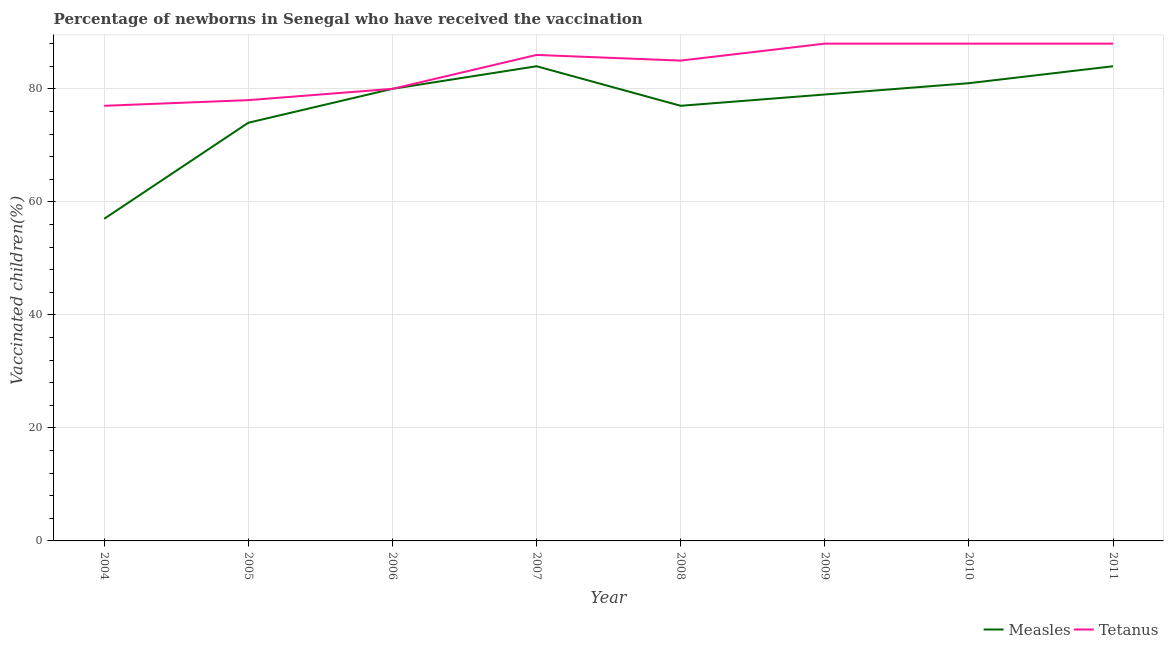How many different coloured lines are there?
Ensure brevity in your answer.  2. Does the line corresponding to percentage of newborns who received vaccination for measles intersect with the line corresponding to percentage of newborns who received vaccination for tetanus?
Make the answer very short. Yes. Is the number of lines equal to the number of legend labels?
Your response must be concise. Yes. What is the percentage of newborns who received vaccination for tetanus in 2009?
Provide a short and direct response. 88. Across all years, what is the maximum percentage of newborns who received vaccination for measles?
Make the answer very short. 84. Across all years, what is the minimum percentage of newborns who received vaccination for tetanus?
Give a very brief answer. 77. In which year was the percentage of newborns who received vaccination for tetanus minimum?
Your answer should be compact. 2004. What is the total percentage of newborns who received vaccination for measles in the graph?
Your response must be concise. 616. What is the difference between the percentage of newborns who received vaccination for measles in 2009 and that in 2011?
Your answer should be very brief. -5. What is the difference between the percentage of newborns who received vaccination for tetanus in 2009 and the percentage of newborns who received vaccination for measles in 2005?
Offer a terse response. 14. In the year 2009, what is the difference between the percentage of newborns who received vaccination for tetanus and percentage of newborns who received vaccination for measles?
Your answer should be very brief. 9. In how many years, is the percentage of newborns who received vaccination for measles greater than 16 %?
Your answer should be very brief. 8. What is the ratio of the percentage of newborns who received vaccination for measles in 2004 to that in 2008?
Keep it short and to the point. 0.74. What is the difference between the highest and the lowest percentage of newborns who received vaccination for measles?
Keep it short and to the point. 27. In how many years, is the percentage of newborns who received vaccination for measles greater than the average percentage of newborns who received vaccination for measles taken over all years?
Offer a very short reply. 5. Is the sum of the percentage of newborns who received vaccination for measles in 2006 and 2008 greater than the maximum percentage of newborns who received vaccination for tetanus across all years?
Provide a short and direct response. Yes. Does the percentage of newborns who received vaccination for measles monotonically increase over the years?
Provide a short and direct response. No. Does the graph contain any zero values?
Make the answer very short. No. Does the graph contain grids?
Ensure brevity in your answer.  Yes. Where does the legend appear in the graph?
Make the answer very short. Bottom right. What is the title of the graph?
Make the answer very short. Percentage of newborns in Senegal who have received the vaccination. Does "Male" appear as one of the legend labels in the graph?
Provide a short and direct response. No. What is the label or title of the Y-axis?
Provide a succinct answer. Vaccinated children(%)
. What is the Vaccinated children(%)
 of Measles in 2004?
Keep it short and to the point. 57. What is the Vaccinated children(%)
 in Measles in 2005?
Offer a very short reply. 74. What is the Vaccinated children(%)
 of Tetanus in 2006?
Offer a very short reply. 80. What is the Vaccinated children(%)
 in Measles in 2009?
Your answer should be very brief. 79. Across all years, what is the maximum Vaccinated children(%)
 of Tetanus?
Provide a short and direct response. 88. Across all years, what is the minimum Vaccinated children(%)
 in Tetanus?
Offer a very short reply. 77. What is the total Vaccinated children(%)
 in Measles in the graph?
Keep it short and to the point. 616. What is the total Vaccinated children(%)
 in Tetanus in the graph?
Your answer should be very brief. 670. What is the difference between the Vaccinated children(%)
 of Measles in 2004 and that in 2006?
Ensure brevity in your answer.  -23. What is the difference between the Vaccinated children(%)
 in Tetanus in 2004 and that in 2007?
Your answer should be very brief. -9. What is the difference between the Vaccinated children(%)
 of Tetanus in 2004 and that in 2008?
Give a very brief answer. -8. What is the difference between the Vaccinated children(%)
 in Tetanus in 2004 and that in 2009?
Give a very brief answer. -11. What is the difference between the Vaccinated children(%)
 of Measles in 2004 and that in 2011?
Your answer should be very brief. -27. What is the difference between the Vaccinated children(%)
 of Tetanus in 2004 and that in 2011?
Keep it short and to the point. -11. What is the difference between the Vaccinated children(%)
 of Tetanus in 2005 and that in 2006?
Your response must be concise. -2. What is the difference between the Vaccinated children(%)
 of Measles in 2005 and that in 2007?
Provide a short and direct response. -10. What is the difference between the Vaccinated children(%)
 of Tetanus in 2005 and that in 2007?
Make the answer very short. -8. What is the difference between the Vaccinated children(%)
 in Measles in 2005 and that in 2008?
Keep it short and to the point. -3. What is the difference between the Vaccinated children(%)
 in Tetanus in 2005 and that in 2008?
Keep it short and to the point. -7. What is the difference between the Vaccinated children(%)
 of Measles in 2005 and that in 2009?
Your answer should be compact. -5. What is the difference between the Vaccinated children(%)
 of Measles in 2005 and that in 2010?
Make the answer very short. -7. What is the difference between the Vaccinated children(%)
 of Tetanus in 2005 and that in 2011?
Make the answer very short. -10. What is the difference between the Vaccinated children(%)
 in Tetanus in 2006 and that in 2008?
Your response must be concise. -5. What is the difference between the Vaccinated children(%)
 in Measles in 2006 and that in 2009?
Give a very brief answer. 1. What is the difference between the Vaccinated children(%)
 of Tetanus in 2006 and that in 2011?
Give a very brief answer. -8. What is the difference between the Vaccinated children(%)
 in Tetanus in 2007 and that in 2008?
Your answer should be very brief. 1. What is the difference between the Vaccinated children(%)
 in Measles in 2007 and that in 2009?
Provide a short and direct response. 5. What is the difference between the Vaccinated children(%)
 in Tetanus in 2007 and that in 2009?
Your answer should be compact. -2. What is the difference between the Vaccinated children(%)
 in Measles in 2007 and that in 2010?
Offer a terse response. 3. What is the difference between the Vaccinated children(%)
 in Measles in 2007 and that in 2011?
Provide a succinct answer. 0. What is the difference between the Vaccinated children(%)
 of Tetanus in 2007 and that in 2011?
Your answer should be very brief. -2. What is the difference between the Vaccinated children(%)
 of Measles in 2008 and that in 2009?
Your answer should be very brief. -2. What is the difference between the Vaccinated children(%)
 of Tetanus in 2008 and that in 2009?
Give a very brief answer. -3. What is the difference between the Vaccinated children(%)
 of Measles in 2008 and that in 2010?
Provide a short and direct response. -4. What is the difference between the Vaccinated children(%)
 in Tetanus in 2008 and that in 2010?
Your response must be concise. -3. What is the difference between the Vaccinated children(%)
 of Measles in 2008 and that in 2011?
Provide a short and direct response. -7. What is the difference between the Vaccinated children(%)
 in Measles in 2009 and that in 2010?
Offer a terse response. -2. What is the difference between the Vaccinated children(%)
 in Measles in 2009 and that in 2011?
Offer a terse response. -5. What is the difference between the Vaccinated children(%)
 of Measles in 2010 and that in 2011?
Provide a short and direct response. -3. What is the difference between the Vaccinated children(%)
 in Tetanus in 2010 and that in 2011?
Your response must be concise. 0. What is the difference between the Vaccinated children(%)
 of Measles in 2004 and the Vaccinated children(%)
 of Tetanus in 2005?
Your answer should be very brief. -21. What is the difference between the Vaccinated children(%)
 of Measles in 2004 and the Vaccinated children(%)
 of Tetanus in 2009?
Give a very brief answer. -31. What is the difference between the Vaccinated children(%)
 in Measles in 2004 and the Vaccinated children(%)
 in Tetanus in 2010?
Keep it short and to the point. -31. What is the difference between the Vaccinated children(%)
 in Measles in 2004 and the Vaccinated children(%)
 in Tetanus in 2011?
Provide a succinct answer. -31. What is the difference between the Vaccinated children(%)
 of Measles in 2005 and the Vaccinated children(%)
 of Tetanus in 2007?
Offer a very short reply. -12. What is the difference between the Vaccinated children(%)
 of Measles in 2005 and the Vaccinated children(%)
 of Tetanus in 2008?
Your answer should be compact. -11. What is the difference between the Vaccinated children(%)
 in Measles in 2005 and the Vaccinated children(%)
 in Tetanus in 2011?
Provide a succinct answer. -14. What is the difference between the Vaccinated children(%)
 of Measles in 2006 and the Vaccinated children(%)
 of Tetanus in 2007?
Your answer should be very brief. -6. What is the difference between the Vaccinated children(%)
 in Measles in 2006 and the Vaccinated children(%)
 in Tetanus in 2008?
Offer a terse response. -5. What is the difference between the Vaccinated children(%)
 of Measles in 2006 and the Vaccinated children(%)
 of Tetanus in 2009?
Offer a terse response. -8. What is the difference between the Vaccinated children(%)
 in Measles in 2006 and the Vaccinated children(%)
 in Tetanus in 2011?
Give a very brief answer. -8. What is the difference between the Vaccinated children(%)
 in Measles in 2007 and the Vaccinated children(%)
 in Tetanus in 2008?
Provide a succinct answer. -1. What is the difference between the Vaccinated children(%)
 in Measles in 2007 and the Vaccinated children(%)
 in Tetanus in 2010?
Ensure brevity in your answer.  -4. What is the difference between the Vaccinated children(%)
 of Measles in 2008 and the Vaccinated children(%)
 of Tetanus in 2009?
Provide a succinct answer. -11. What is the difference between the Vaccinated children(%)
 in Measles in 2008 and the Vaccinated children(%)
 in Tetanus in 2011?
Your response must be concise. -11. What is the difference between the Vaccinated children(%)
 of Measles in 2009 and the Vaccinated children(%)
 of Tetanus in 2010?
Your answer should be compact. -9. What is the average Vaccinated children(%)
 of Tetanus per year?
Offer a very short reply. 83.75. In the year 2004, what is the difference between the Vaccinated children(%)
 of Measles and Vaccinated children(%)
 of Tetanus?
Your answer should be very brief. -20. In the year 2005, what is the difference between the Vaccinated children(%)
 of Measles and Vaccinated children(%)
 of Tetanus?
Your response must be concise. -4. In the year 2006, what is the difference between the Vaccinated children(%)
 of Measles and Vaccinated children(%)
 of Tetanus?
Offer a terse response. 0. In the year 2007, what is the difference between the Vaccinated children(%)
 in Measles and Vaccinated children(%)
 in Tetanus?
Give a very brief answer. -2. In the year 2009, what is the difference between the Vaccinated children(%)
 of Measles and Vaccinated children(%)
 of Tetanus?
Make the answer very short. -9. What is the ratio of the Vaccinated children(%)
 of Measles in 2004 to that in 2005?
Provide a short and direct response. 0.77. What is the ratio of the Vaccinated children(%)
 in Tetanus in 2004 to that in 2005?
Keep it short and to the point. 0.99. What is the ratio of the Vaccinated children(%)
 of Measles in 2004 to that in 2006?
Give a very brief answer. 0.71. What is the ratio of the Vaccinated children(%)
 in Tetanus in 2004 to that in 2006?
Provide a short and direct response. 0.96. What is the ratio of the Vaccinated children(%)
 in Measles in 2004 to that in 2007?
Offer a very short reply. 0.68. What is the ratio of the Vaccinated children(%)
 in Tetanus in 2004 to that in 2007?
Your answer should be very brief. 0.9. What is the ratio of the Vaccinated children(%)
 of Measles in 2004 to that in 2008?
Ensure brevity in your answer.  0.74. What is the ratio of the Vaccinated children(%)
 of Tetanus in 2004 to that in 2008?
Offer a terse response. 0.91. What is the ratio of the Vaccinated children(%)
 in Measles in 2004 to that in 2009?
Make the answer very short. 0.72. What is the ratio of the Vaccinated children(%)
 of Tetanus in 2004 to that in 2009?
Offer a very short reply. 0.88. What is the ratio of the Vaccinated children(%)
 in Measles in 2004 to that in 2010?
Provide a succinct answer. 0.7. What is the ratio of the Vaccinated children(%)
 in Tetanus in 2004 to that in 2010?
Offer a very short reply. 0.88. What is the ratio of the Vaccinated children(%)
 of Measles in 2004 to that in 2011?
Offer a very short reply. 0.68. What is the ratio of the Vaccinated children(%)
 in Measles in 2005 to that in 2006?
Keep it short and to the point. 0.93. What is the ratio of the Vaccinated children(%)
 of Measles in 2005 to that in 2007?
Ensure brevity in your answer.  0.88. What is the ratio of the Vaccinated children(%)
 of Tetanus in 2005 to that in 2007?
Your response must be concise. 0.91. What is the ratio of the Vaccinated children(%)
 in Measles in 2005 to that in 2008?
Your answer should be compact. 0.96. What is the ratio of the Vaccinated children(%)
 in Tetanus in 2005 to that in 2008?
Give a very brief answer. 0.92. What is the ratio of the Vaccinated children(%)
 in Measles in 2005 to that in 2009?
Provide a succinct answer. 0.94. What is the ratio of the Vaccinated children(%)
 of Tetanus in 2005 to that in 2009?
Provide a succinct answer. 0.89. What is the ratio of the Vaccinated children(%)
 in Measles in 2005 to that in 2010?
Offer a very short reply. 0.91. What is the ratio of the Vaccinated children(%)
 in Tetanus in 2005 to that in 2010?
Offer a terse response. 0.89. What is the ratio of the Vaccinated children(%)
 of Measles in 2005 to that in 2011?
Offer a very short reply. 0.88. What is the ratio of the Vaccinated children(%)
 in Tetanus in 2005 to that in 2011?
Offer a very short reply. 0.89. What is the ratio of the Vaccinated children(%)
 in Tetanus in 2006 to that in 2007?
Offer a very short reply. 0.93. What is the ratio of the Vaccinated children(%)
 in Measles in 2006 to that in 2008?
Make the answer very short. 1.04. What is the ratio of the Vaccinated children(%)
 in Measles in 2006 to that in 2009?
Give a very brief answer. 1.01. What is the ratio of the Vaccinated children(%)
 of Tetanus in 2006 to that in 2009?
Provide a succinct answer. 0.91. What is the ratio of the Vaccinated children(%)
 in Tetanus in 2006 to that in 2010?
Offer a terse response. 0.91. What is the ratio of the Vaccinated children(%)
 in Tetanus in 2006 to that in 2011?
Provide a succinct answer. 0.91. What is the ratio of the Vaccinated children(%)
 in Measles in 2007 to that in 2008?
Your answer should be very brief. 1.09. What is the ratio of the Vaccinated children(%)
 in Tetanus in 2007 to that in 2008?
Your answer should be very brief. 1.01. What is the ratio of the Vaccinated children(%)
 of Measles in 2007 to that in 2009?
Offer a very short reply. 1.06. What is the ratio of the Vaccinated children(%)
 of Tetanus in 2007 to that in 2009?
Give a very brief answer. 0.98. What is the ratio of the Vaccinated children(%)
 in Tetanus in 2007 to that in 2010?
Keep it short and to the point. 0.98. What is the ratio of the Vaccinated children(%)
 in Tetanus in 2007 to that in 2011?
Make the answer very short. 0.98. What is the ratio of the Vaccinated children(%)
 in Measles in 2008 to that in 2009?
Offer a very short reply. 0.97. What is the ratio of the Vaccinated children(%)
 in Tetanus in 2008 to that in 2009?
Your response must be concise. 0.97. What is the ratio of the Vaccinated children(%)
 of Measles in 2008 to that in 2010?
Provide a succinct answer. 0.95. What is the ratio of the Vaccinated children(%)
 of Tetanus in 2008 to that in 2010?
Ensure brevity in your answer.  0.97. What is the ratio of the Vaccinated children(%)
 in Measles in 2008 to that in 2011?
Provide a succinct answer. 0.92. What is the ratio of the Vaccinated children(%)
 in Tetanus in 2008 to that in 2011?
Provide a succinct answer. 0.97. What is the ratio of the Vaccinated children(%)
 in Measles in 2009 to that in 2010?
Provide a short and direct response. 0.98. What is the ratio of the Vaccinated children(%)
 of Tetanus in 2009 to that in 2010?
Your answer should be very brief. 1. What is the ratio of the Vaccinated children(%)
 of Measles in 2009 to that in 2011?
Make the answer very short. 0.94. What is the ratio of the Vaccinated children(%)
 of Measles in 2010 to that in 2011?
Your response must be concise. 0.96. What is the ratio of the Vaccinated children(%)
 in Tetanus in 2010 to that in 2011?
Give a very brief answer. 1. What is the difference between the highest and the second highest Vaccinated children(%)
 in Measles?
Provide a short and direct response. 0. What is the difference between the highest and the second highest Vaccinated children(%)
 of Tetanus?
Offer a very short reply. 0. What is the difference between the highest and the lowest Vaccinated children(%)
 in Measles?
Make the answer very short. 27. What is the difference between the highest and the lowest Vaccinated children(%)
 of Tetanus?
Your response must be concise. 11. 